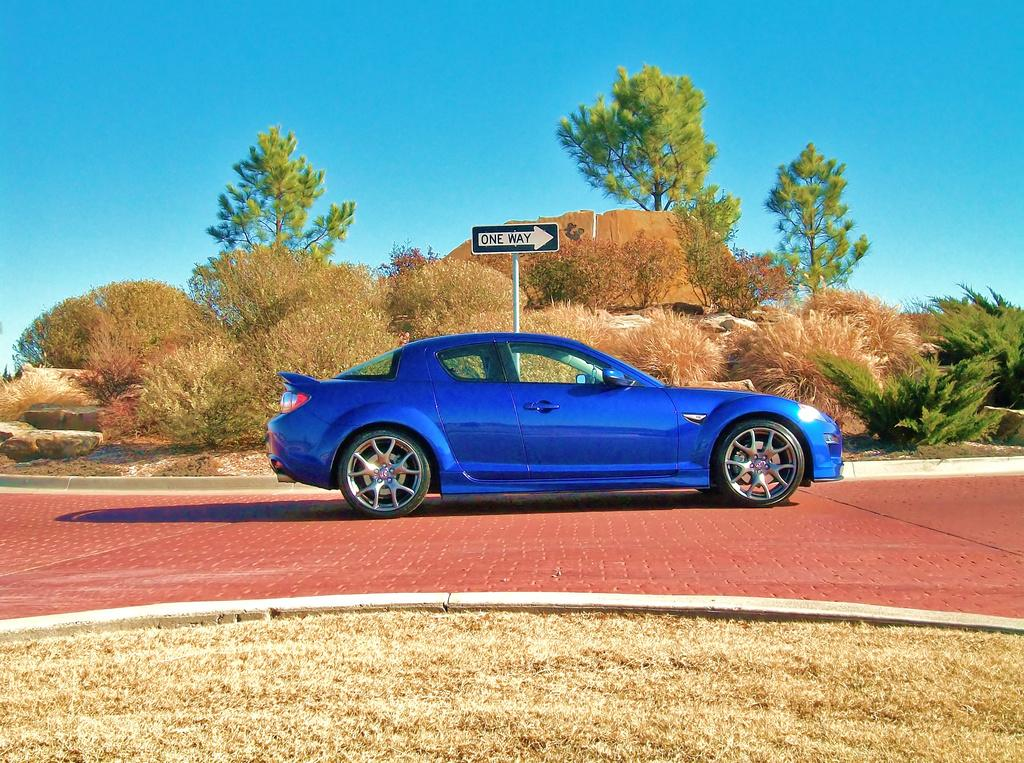What is the main subject in the center of the image? There is a car in the center of the image. What color is the car? The car is blue. What can be seen in the background of the image? There are bushes and trees in the background of the image. What is the purpose of the sign board in the image? The purpose of the sign board in the image is not specified, but it may provide information or directions. What is visible at the top of the image? The sky is visible at the top of the image. What type of curtain is hanging from the sky in the image? There is no curtain hanging from the sky in the image; the sky is visible without any curtains. 